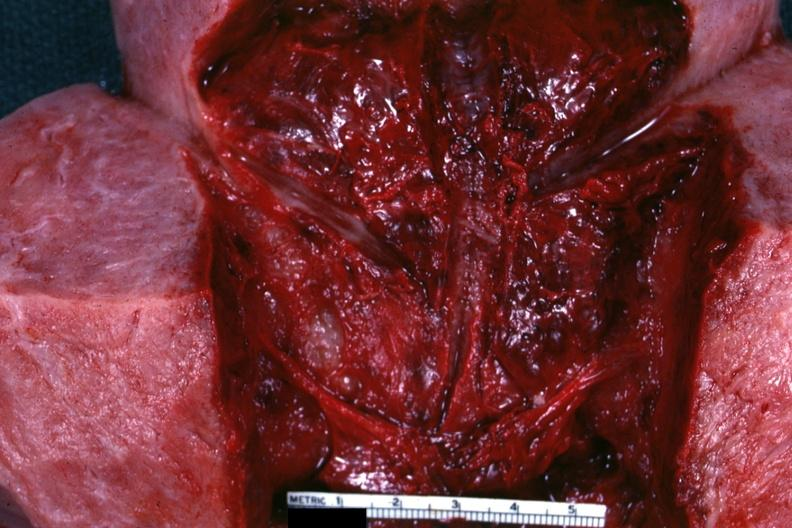s female reproductive present?
Answer the question using a single word or phrase. Yes 